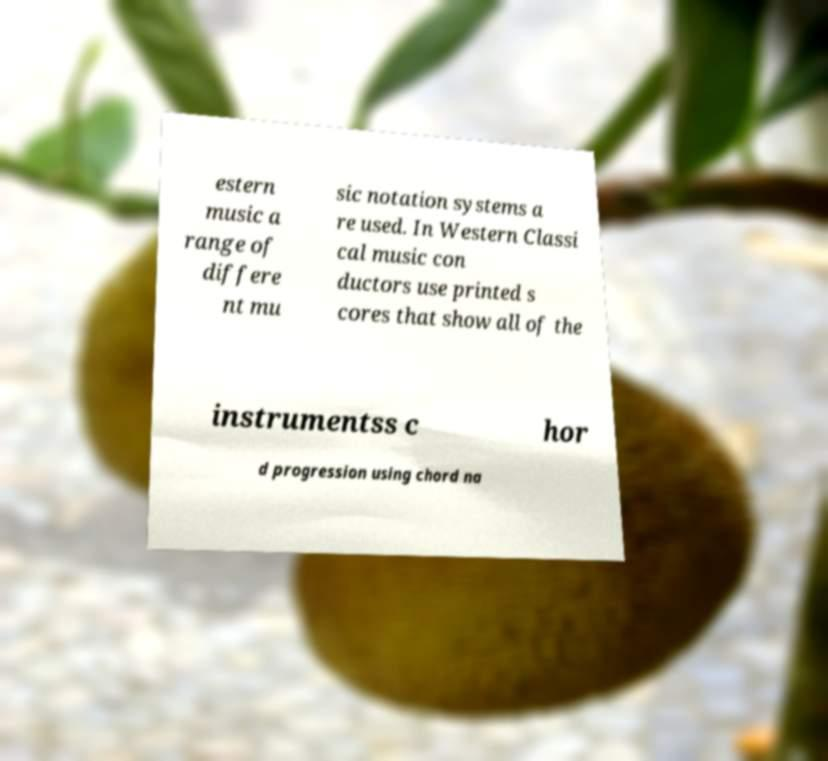For documentation purposes, I need the text within this image transcribed. Could you provide that? estern music a range of differe nt mu sic notation systems a re used. In Western Classi cal music con ductors use printed s cores that show all of the instrumentss c hor d progression using chord na 